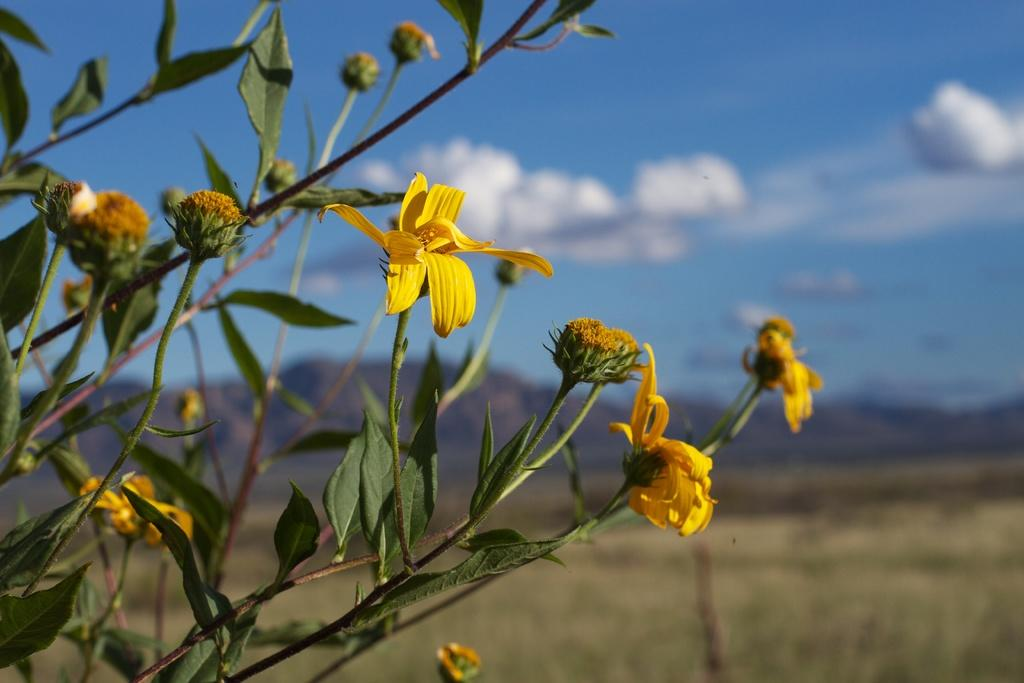What type of plant is in the image? The image contains a plant with flowers and buds. Can you describe the plant's flowers? The flowers are visible on the plant. What else can be seen on the plant besides flowers? The plant has buds. What is visible in the background of the image? The background of the image is blurry. What can be seen in the sky in the image? Clouds are visible in the image. What type of screw can be seen holding the plant to the ground in the image? There is no screw visible in the image; the plant is not attached to the ground. What color is the jelly in the image? There is no jelly present in the image. 